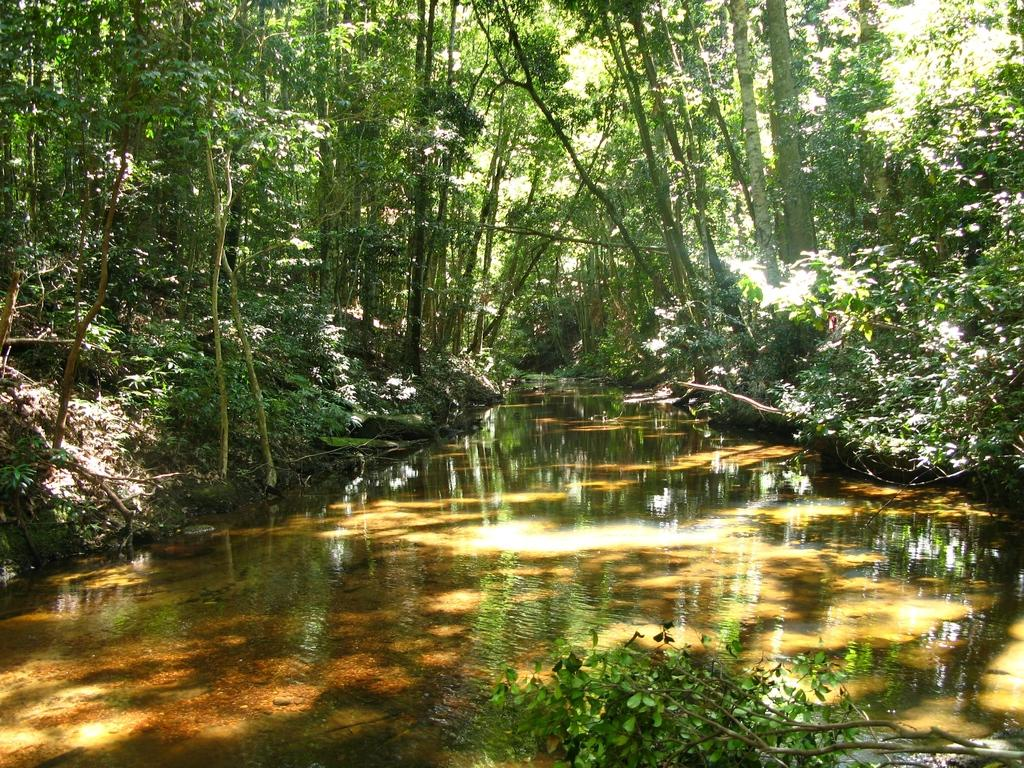What is the main feature in the center of the image? There is a canal in the center of the image. What can be seen in the background of the image? There are trees in the background of the image. What is the purpose of the scent in the image? There is no mention of a scent in the image, so it cannot be determined what its purpose might be. 